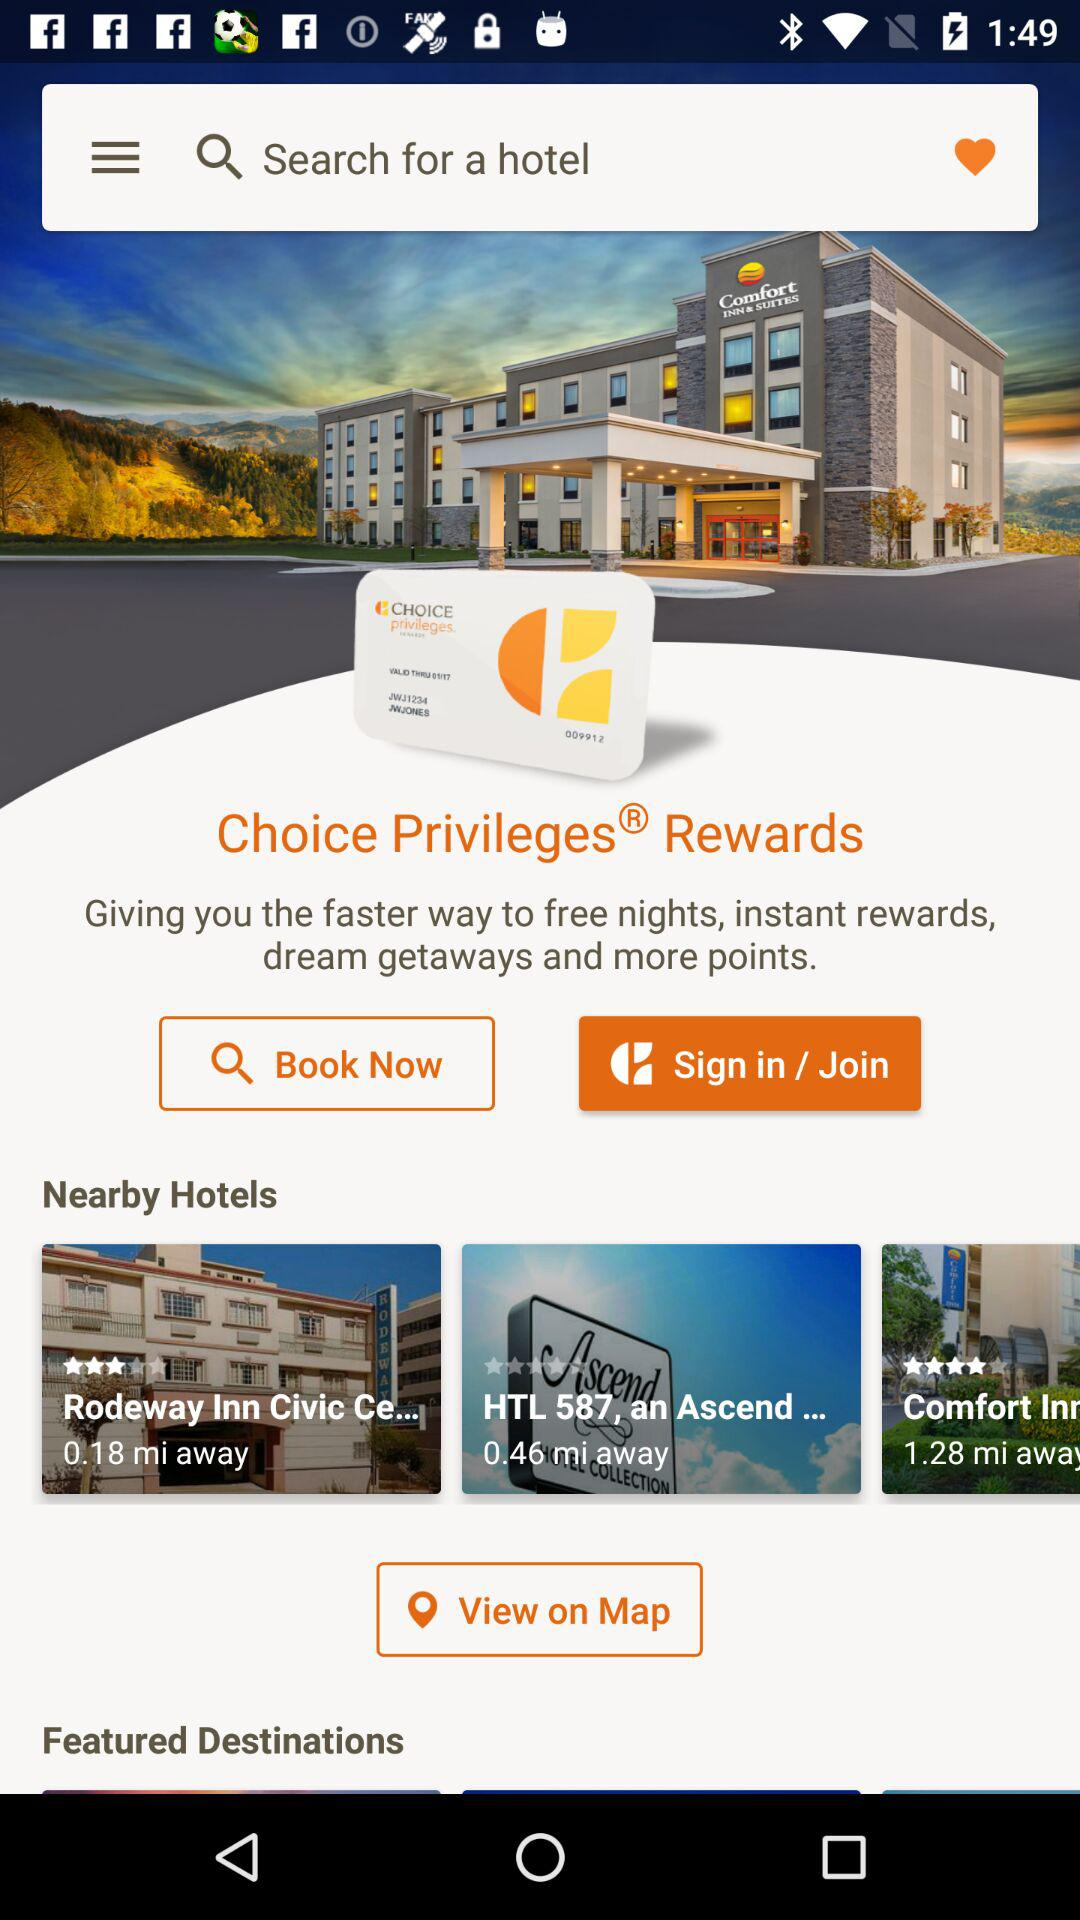What is the name of nearby hotels? The name of nearby hotels are "Rodeway Inn Civic Ce..." and "HTL 587, an Ascend...". 